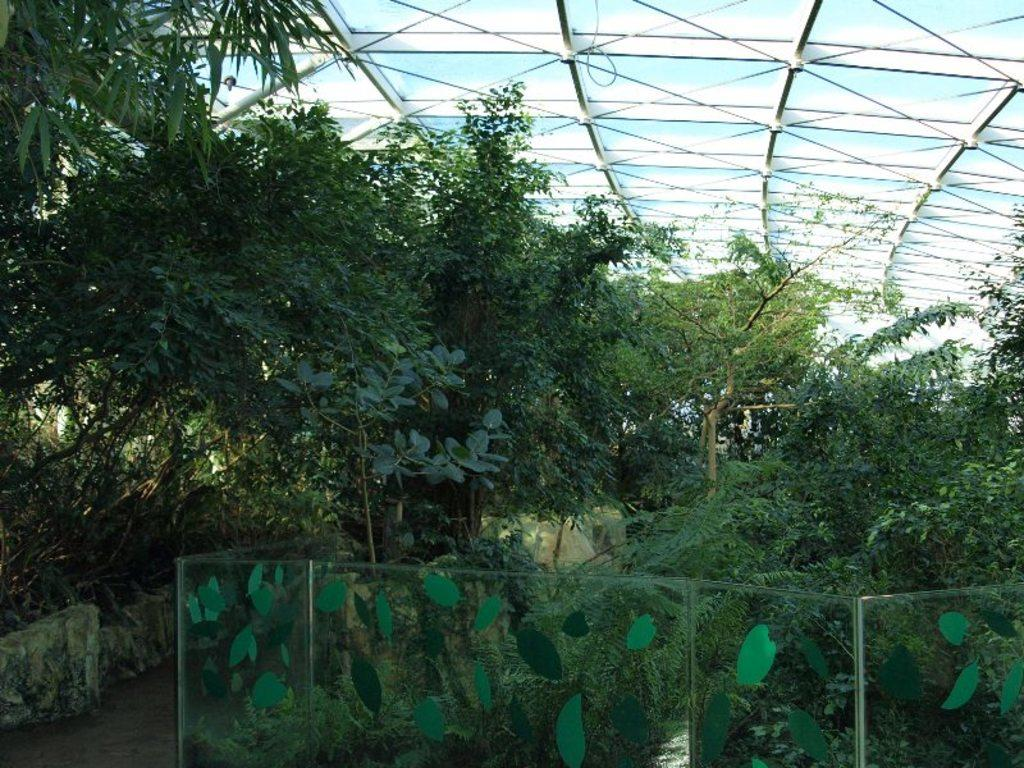What type of fence is visible in the image? There is a glass fence in the image. What other natural elements can be seen in the image? There are plants and trees in the image. What type of structure is present in the image? There is a shed with rods at the top of the image. Can you see a group of people flying a kite in the image? There is no group of people flying a kite in the image. Is there a zipper on any of the plants or trees in the image? There are no zippers present on the plants or trees in the image. 